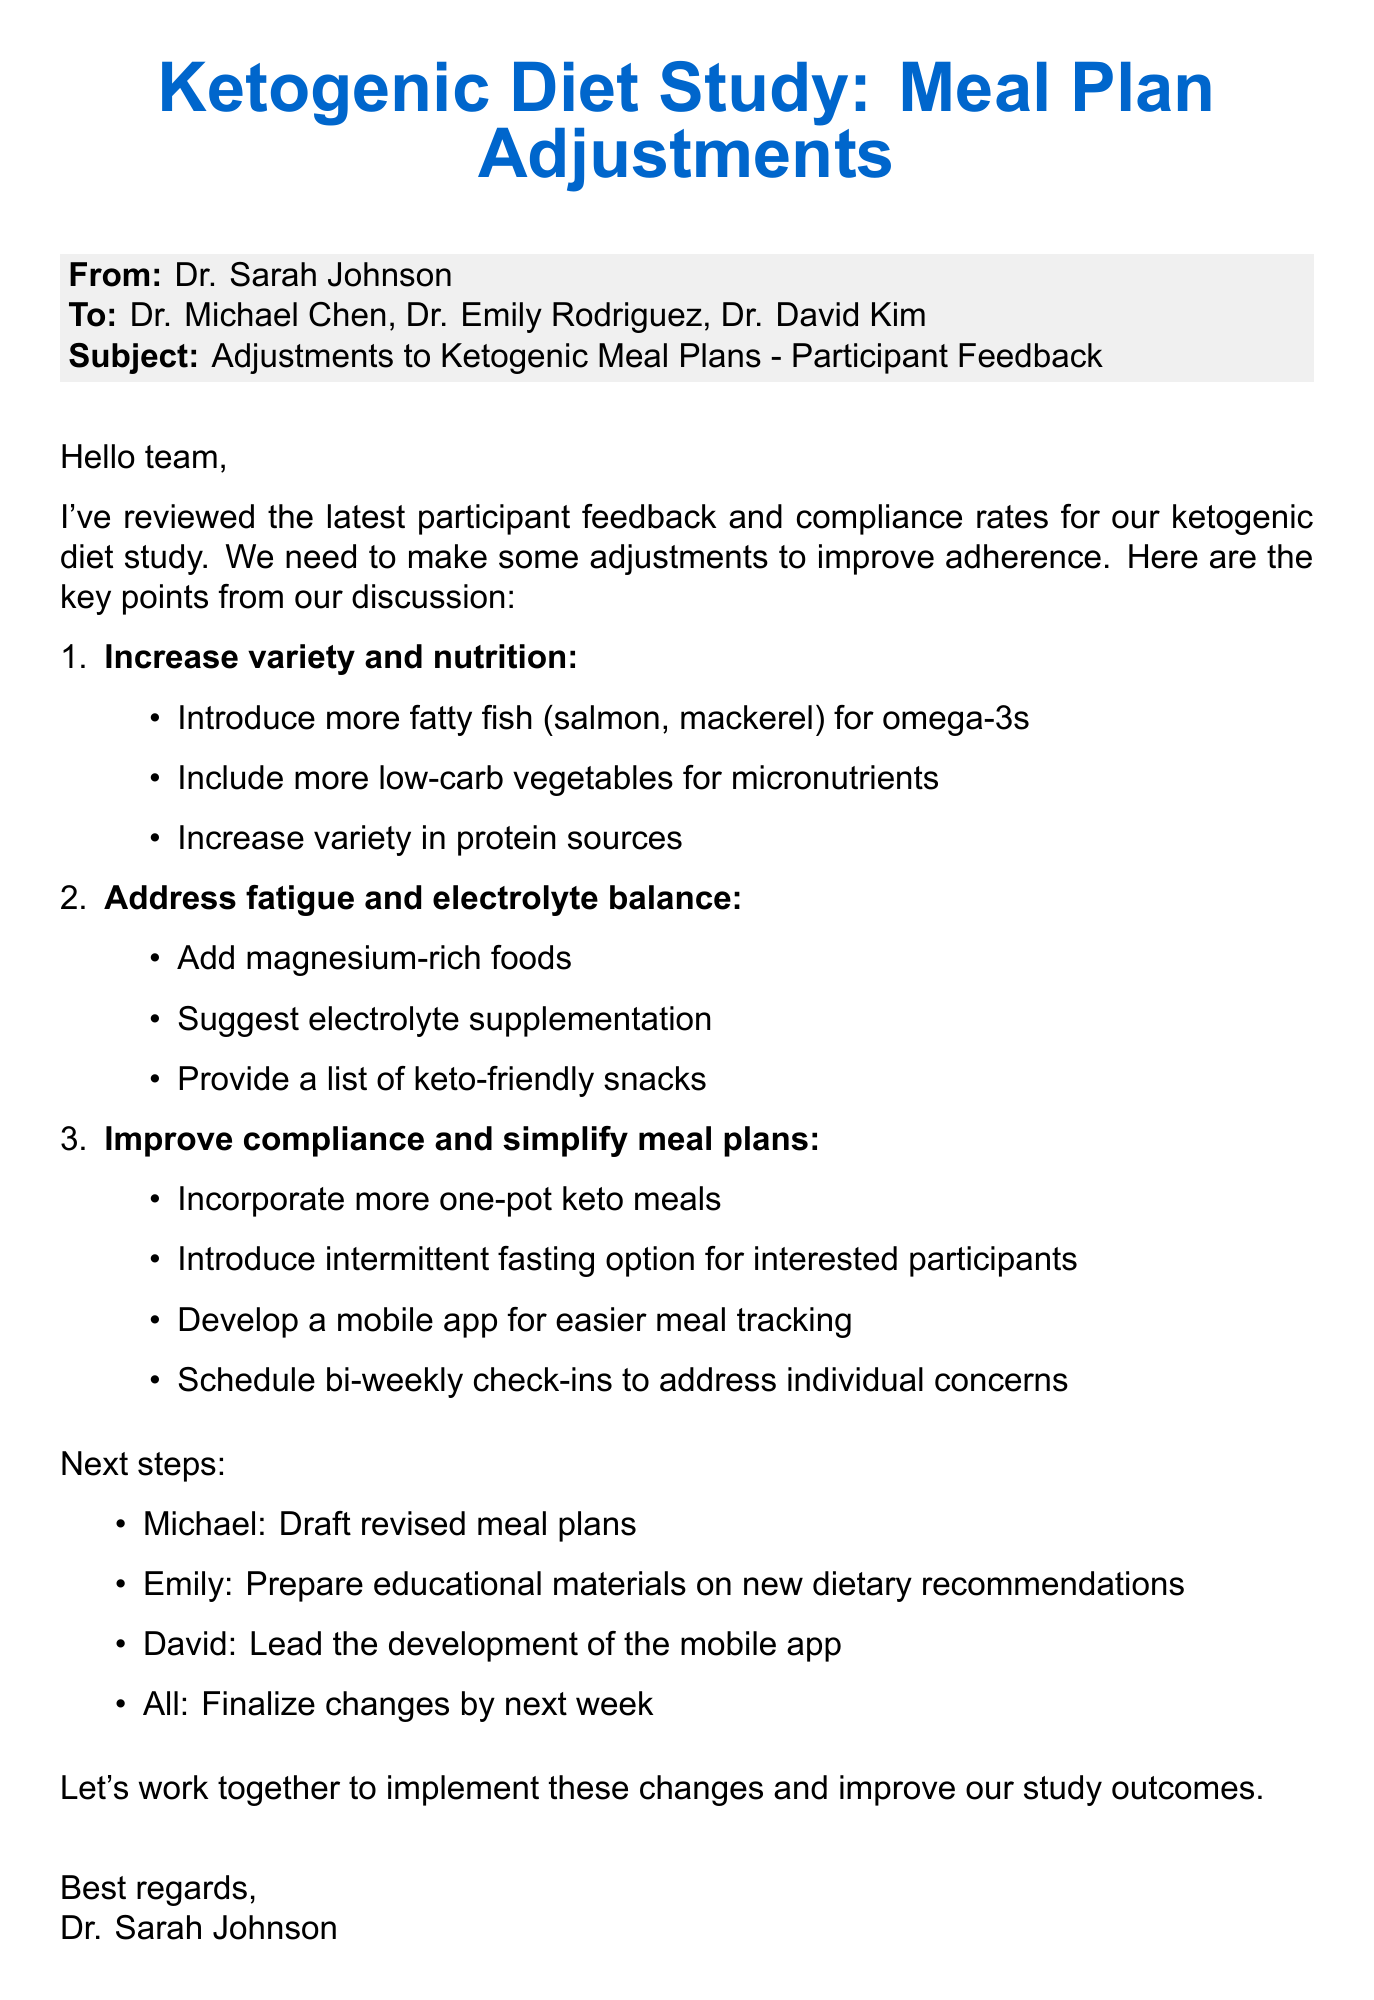What is the main subject of the email? The subject of the email discusses potential adjustments to the ketogenic meal plans based on feedback.
Answer: Adjustments to Ketogenic Meal Plans - Participant Feedback Who is the sender of the email? The email is sent by Dr. Sarah Johnson.
Answer: Dr. Sarah Johnson Which protein sources are suggested to increase in variety? The suggestions include increasing the variety in protein sources mentioned in the email.
Answer: Protein sources What specific food types does Michael suggest for omega-3s? Michael mentioned introducing more fatty fish like salmon and mackerel for omega-3s.
Answer: Fatty fish (salmon, mackerel) What additional dietary recommendation did Emily make? Emily suggested including more low-carb vegetables for micronutrients.
Answer: Low-carb vegetables How often should bi-weekly check-ins occur? The term "bi-weekly" indicates that the check-ins should occur every two weeks.
Answer: Every two weeks Who is responsible for leading mobile app development? David has offered to lead the app development for meal tracking.
Answer: David What is the proposed deadline for finalizing changes? The email suggests that the team aims to finalize changes by next week.
Answer: Next week 